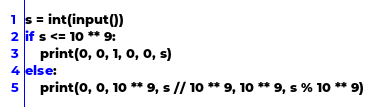Convert code to text. <code><loc_0><loc_0><loc_500><loc_500><_Python_>s = int(input())
if s <= 10 ** 9:
    print(0, 0, 1, 0, 0, s)
else:
    print(0, 0, 10 ** 9, s // 10 ** 9, 10 ** 9, s % 10 ** 9)</code> 